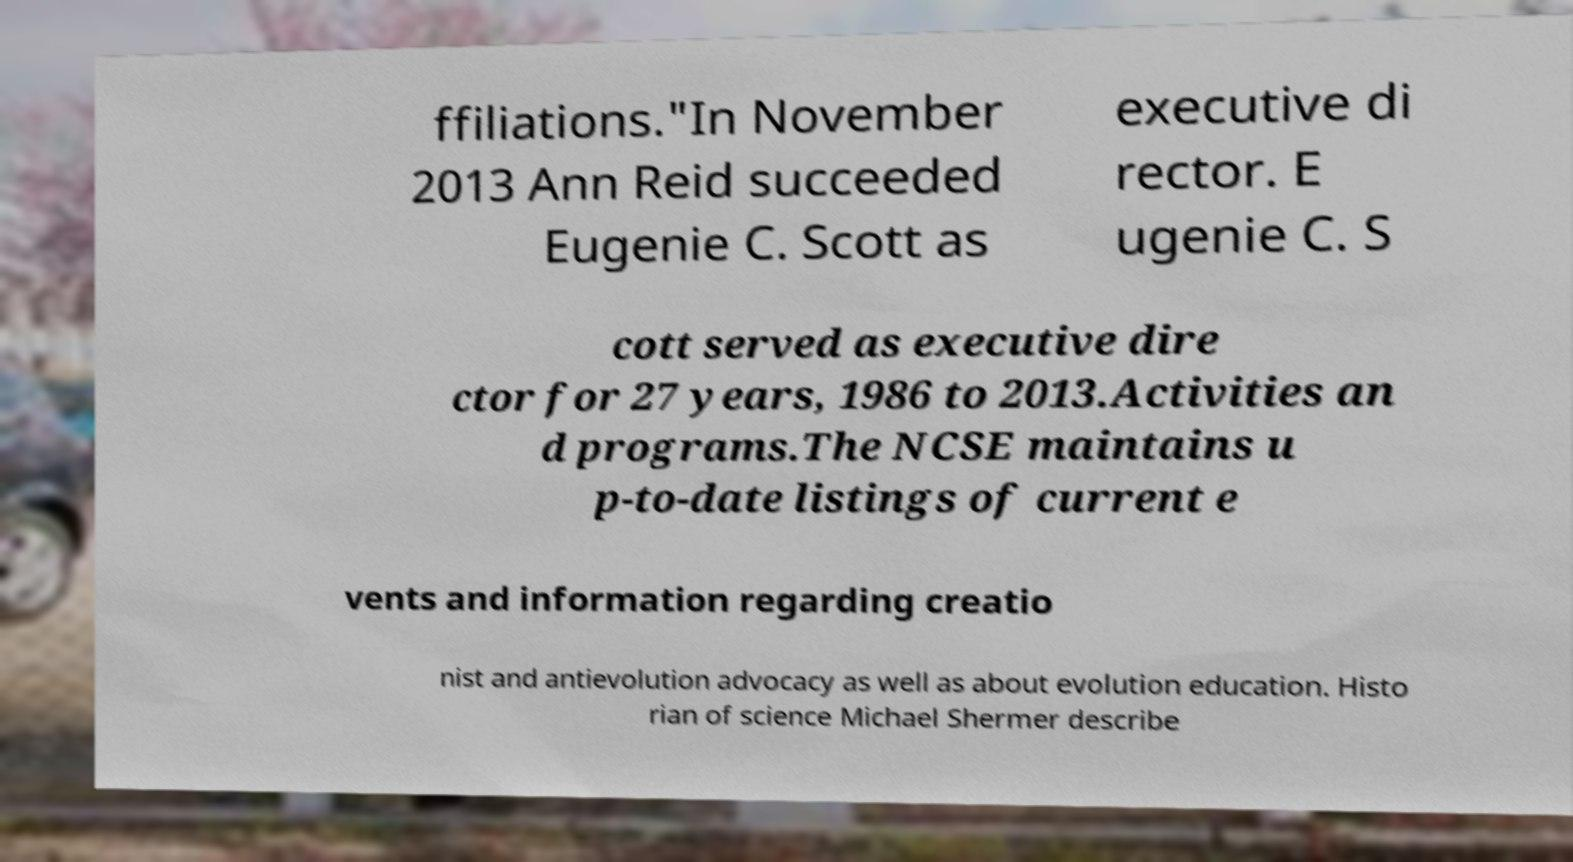There's text embedded in this image that I need extracted. Can you transcribe it verbatim? ffiliations."In November 2013 Ann Reid succeeded Eugenie C. Scott as executive di rector. E ugenie C. S cott served as executive dire ctor for 27 years, 1986 to 2013.Activities an d programs.The NCSE maintains u p-to-date listings of current e vents and information regarding creatio nist and antievolution advocacy as well as about evolution education. Histo rian of science Michael Shermer describe 